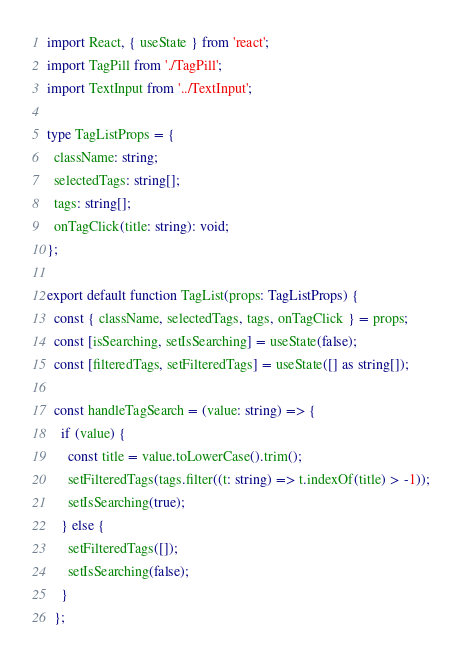Convert code to text. <code><loc_0><loc_0><loc_500><loc_500><_TypeScript_>import React, { useState } from 'react';
import TagPill from './TagPill';
import TextInput from '../TextInput';

type TagListProps = {
  className: string;
  selectedTags: string[];
  tags: string[];
  onTagClick(title: string): void;
};

export default function TagList(props: TagListProps) {
  const { className, selectedTags, tags, onTagClick } = props;
  const [isSearching, setIsSearching] = useState(false);
  const [filteredTags, setFilteredTags] = useState([] as string[]);

  const handleTagSearch = (value: string) => {
    if (value) {
      const title = value.toLowerCase().trim();
      setFilteredTags(tags.filter((t: string) => t.indexOf(title) > -1));
      setIsSearching(true);
    } else {
      setFilteredTags([]);
      setIsSearching(false);
    }
  };
</code> 